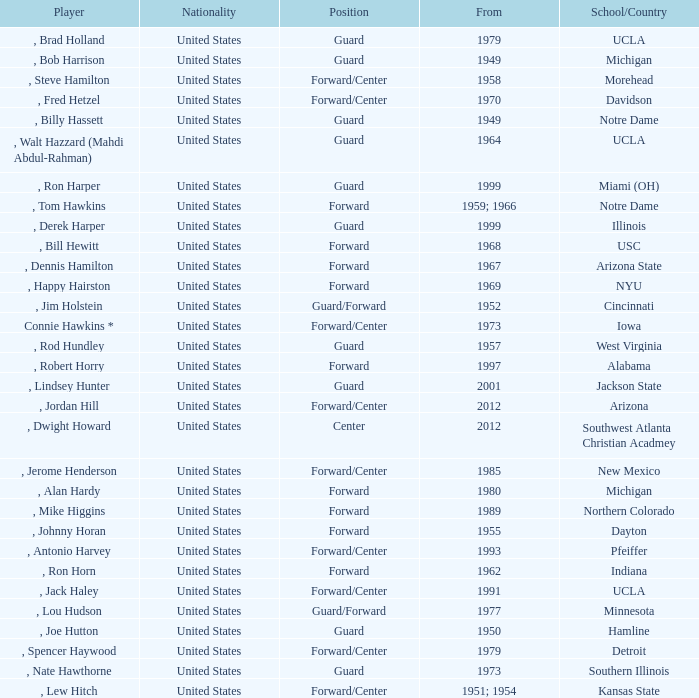Which player started in 2001? , Lindsey Hunter. 